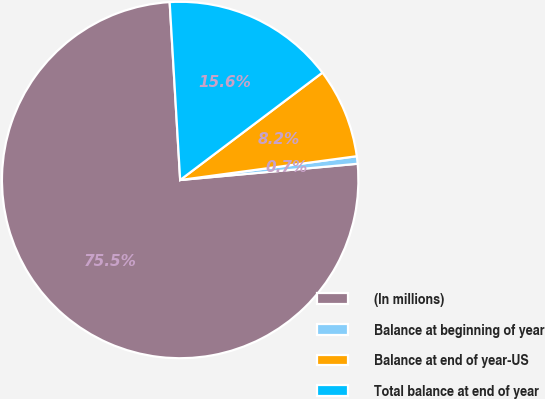<chart> <loc_0><loc_0><loc_500><loc_500><pie_chart><fcel>(In millions)<fcel>Balance at beginning of year<fcel>Balance at end of year-US<fcel>Total balance at end of year<nl><fcel>75.52%<fcel>0.68%<fcel>8.16%<fcel>15.65%<nl></chart> 